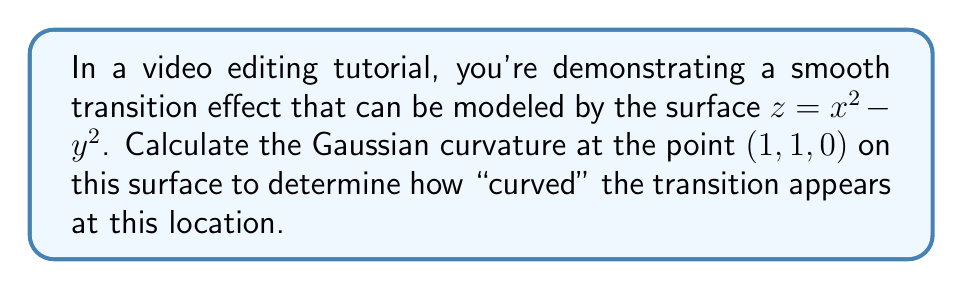Teach me how to tackle this problem. To compute the Gaussian curvature of the surface $z = x^2 - y^2$ at the point (1, 1, 0), we'll follow these steps:

1) First, recall that the Gaussian curvature K is given by:

   $K = \frac{LN - M^2}{EG - F^2}$

   where L, M, N are coefficients of the second fundamental form, and E, F, G are coefficients of the first fundamental form.

2) Let's start by calculating the partial derivatives:
   
   $z_x = 2x$, $z_y = -2y$
   $z_{xx} = 2$, $z_{xy} = 0$, $z_{yy} = -2$

3) Now we can calculate E, F, and G:

   $E = 1 + z_x^2 = 1 + 4x^2$
   $F = z_x z_y = -4xy$
   $G = 1 + z_y^2 = 1 + 4y^2$

4) Next, we calculate the unit normal vector:

   $\vec{N} = \frac{(-z_x, -z_y, 1)}{\sqrt{1 + z_x^2 + z_y^2}} = \frac{(-2x, 2y, 1)}{\sqrt{1 + 4x^2 + 4y^2}}$

5) Now we can calculate L, M, and N:

   $L = \frac{z_{xx}}{\sqrt{1 + z_x^2 + z_y^2}} = \frac{2}{\sqrt{1 + 4x^2 + 4y^2}}$
   
   $M = \frac{z_{xy}}{\sqrt{1 + z_x^2 + z_y^2}} = 0$
   
   $N = \frac{z_{yy}}{\sqrt{1 + z_x^2 + z_y^2}} = \frac{-2}{\sqrt{1 + 4x^2 + 4y^2}}$

6) Now we can substitute all these values into the formula for K:

   $K = \frac{LN - M^2}{EG - F^2} = \frac{(\frac{2}{\sqrt{1 + 4x^2 + 4y^2}})(\frac{-2}{\sqrt{1 + 4x^2 + 4y^2}}) - 0^2}{(1 + 4x^2)(1 + 4y^2) - (-4xy)^2}$

7) Simplify:

   $K = \frac{-4}{(1 + 4x^2 + 4y^2)((1 + 4x^2)(1 + 4y^2) - 16x^2y^2)}$

8) At the point (1, 1, 0), we have x = 1 and y = 1. Substituting these values:

   $K = \frac{-4}{(1 + 4 + 4)((1 + 4)(1 + 4) - 16)} = \frac{-4}{9(25 - 16)} = \frac{-4}{81} = -\frac{4}{81}$

Therefore, the Gaussian curvature at the point (1, 1, 0) is $-\frac{4}{81}$.
Answer: $-\frac{4}{81}$ 